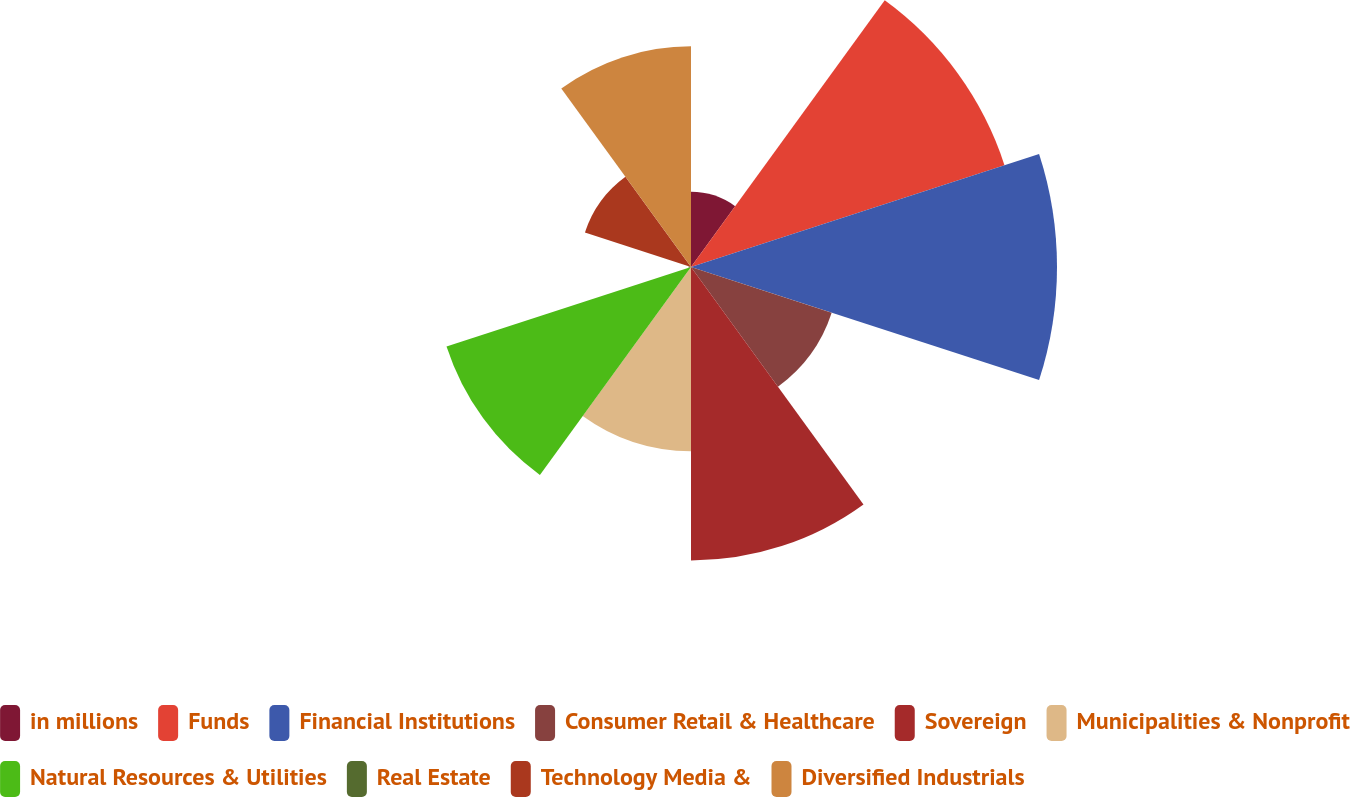<chart> <loc_0><loc_0><loc_500><loc_500><pie_chart><fcel>in millions<fcel>Funds<fcel>Financial Institutions<fcel>Consumer Retail & Healthcare<fcel>Sovereign<fcel>Municipalities & Nonprofit<fcel>Natural Resources & Utilities<fcel>Real Estate<fcel>Technology Media &<fcel>Diversified Industrials<nl><fcel>3.78%<fcel>16.58%<fcel>18.41%<fcel>7.44%<fcel>14.76%<fcel>9.27%<fcel>12.93%<fcel>0.12%<fcel>5.61%<fcel>11.1%<nl></chart> 